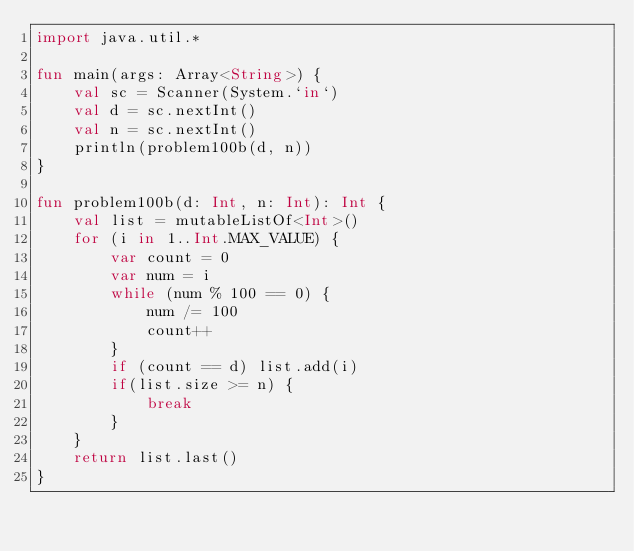Convert code to text. <code><loc_0><loc_0><loc_500><loc_500><_Kotlin_>import java.util.*

fun main(args: Array<String>) {
    val sc = Scanner(System.`in`)
    val d = sc.nextInt()
    val n = sc.nextInt()
    println(problem100b(d, n))
}

fun problem100b(d: Int, n: Int): Int {
    val list = mutableListOf<Int>()
    for (i in 1..Int.MAX_VALUE) {
        var count = 0
        var num = i
        while (num % 100 == 0) {
            num /= 100
            count++
        }
        if (count == d) list.add(i)
        if(list.size >= n) {
            break
        }
    }
    return list.last()
}</code> 